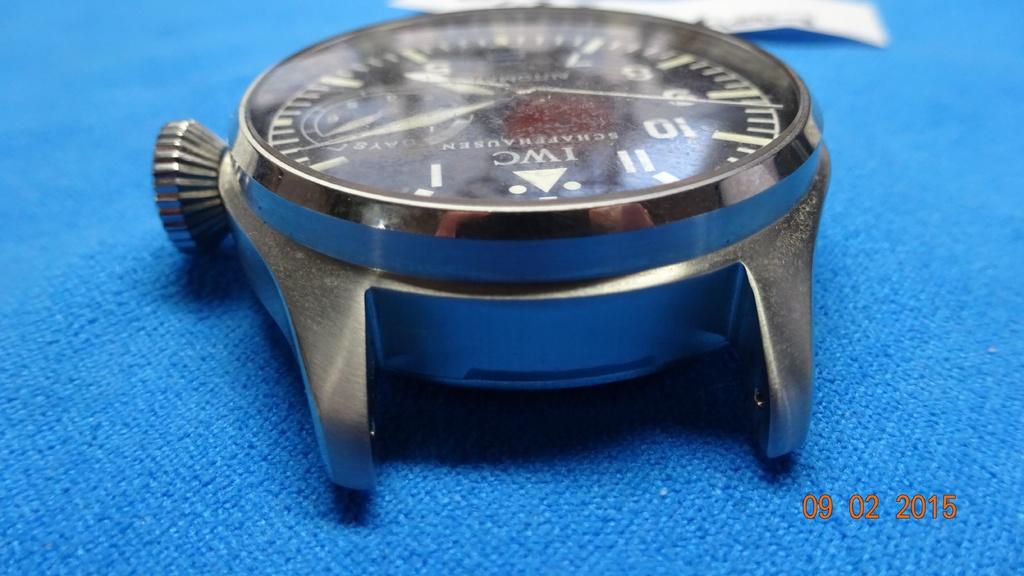When was this photo taken?
Provide a succinct answer. 09 02 2015. What brand is that watch?
Offer a terse response. Iwc. 